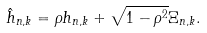<formula> <loc_0><loc_0><loc_500><loc_500>& \hat { h } _ { n , k } = \rho h _ { n , k } + \sqrt { 1 - \rho ^ { 2 } } \Xi _ { n , k } .</formula> 